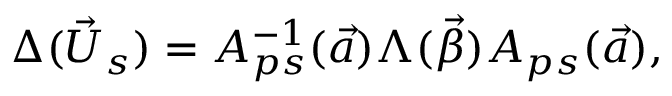Convert formula to latex. <formula><loc_0><loc_0><loc_500><loc_500>\Delta ( \vec { U } _ { s } ) = A _ { p s } ^ { - 1 } ( \vec { a } ) \Lambda ( \vec { \beta } ) A _ { p s } ( \vec { a } ) ,</formula> 